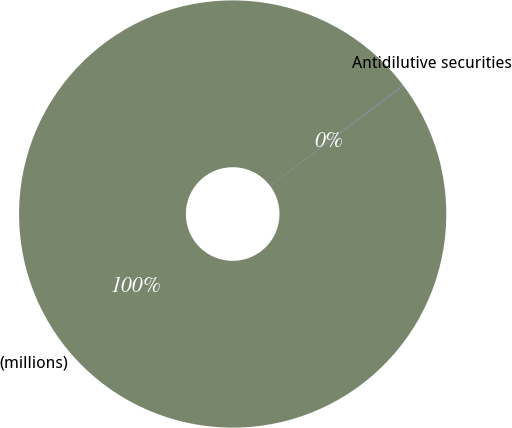Convert chart. <chart><loc_0><loc_0><loc_500><loc_500><pie_chart><fcel>(millions)<fcel>Antidilutive securities<nl><fcel>99.97%<fcel>0.03%<nl></chart> 